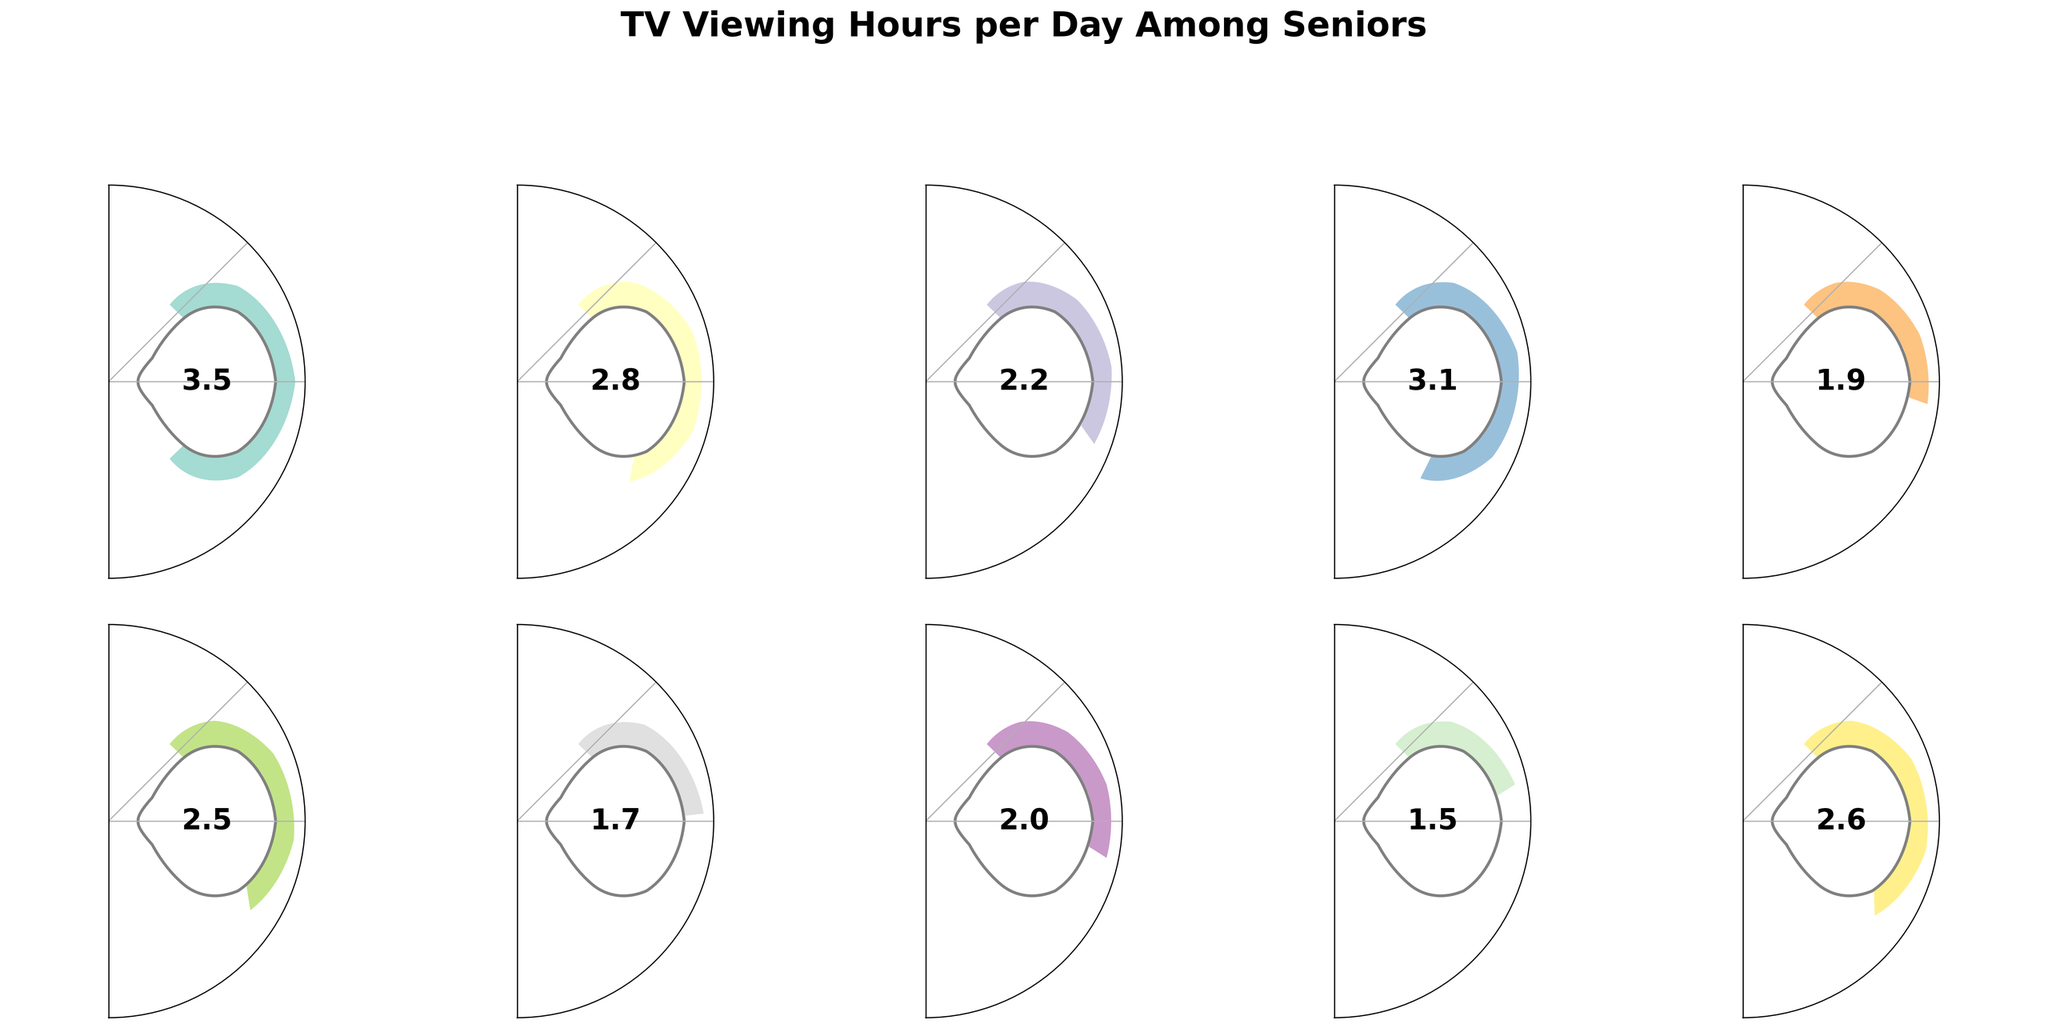What's the title of the figure? The title of the figure is usually located at the top of the image and summarises the main focus of the data. In this case, it's "TV Viewing Hours per Day Among Seniors".
Answer: TV Viewing Hours per Day Among Seniors Which genre has the highest TV viewing hours? By looking at the gauges, we can see which one reaches the largest angle. The genre with the highest hours is News, which reaches 3.5 hours.
Answer: News How many genres have viewing hours of 2.5 or higher? By inspecting the gauges, we see the genres News (3.5), Game Shows (2.8), Classic Sitcoms (3.1), and Classic Movies (2.6), summing to a total of 4 genres with viewing hours of 2.5 or higher.
Answer: 4 What's the average viewing time across all the genres? Sum the hours for all genres (3.5 + 2.8 + 2.2 + 3.1 + 1.9 + 2.5 + 1.7 + 2.0 + 1.5 + 2.6) = 23.8 and divide by the number of genres (10). The average is 23.8 / 10 = 2.38 hours.
Answer: 2.38 hours Which genres have lower average viewing hours than the overall average? First, calculate the overall average viewing hours as 2.38 hours. Then compare each genre: Documentaries (1.7), Soap Operas (1.9), Crime Dramas (2.0), and Variety Shows (1.5) have viewing hours lower than the average.
Answer: Documentaries, Soap Operas, Crime Dramas, Variety Shows Which genre has the smallest TV viewing hours? By comparing the smallest angle on all gauges, Variety Shows has the least viewing hours with 1.5 hours.
Answer: Variety Shows By how many hours do News surpass Westerns in viewing time? News has 3.5 hours, and Westerns have 2.2 hours, so: 3.5 - 2.2 = 1.3 hours.
Answer: 1.3 hours What's the difference in TV viewing hours between Classic Sitcoms and Documentaries? Classic Sitcoms has 3.1 hours, and Documentaries have 1.7 hours, so: 3.1 - 1.7 = 1.4 hours.
Answer: 1.4 hours Which genres have TV viewing hours within 0.3 hours of Game Shows? Game Shows have 2.8 hours. We look for genres between 2.5 and 3.1 hours: Classic Sitcoms (3.1), and Classic Movies (2.6) fall within this range.
Answer: Classic Sitcoms, Classic Movies 